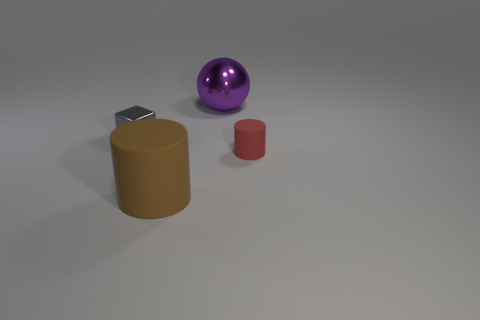Add 4 purple metallic spheres. How many objects exist? 8 Subtract all spheres. How many objects are left? 3 Subtract 0 green spheres. How many objects are left? 4 Subtract all tiny cylinders. Subtract all big yellow rubber blocks. How many objects are left? 3 Add 4 metal cubes. How many metal cubes are left? 5 Add 4 blue spheres. How many blue spheres exist? 4 